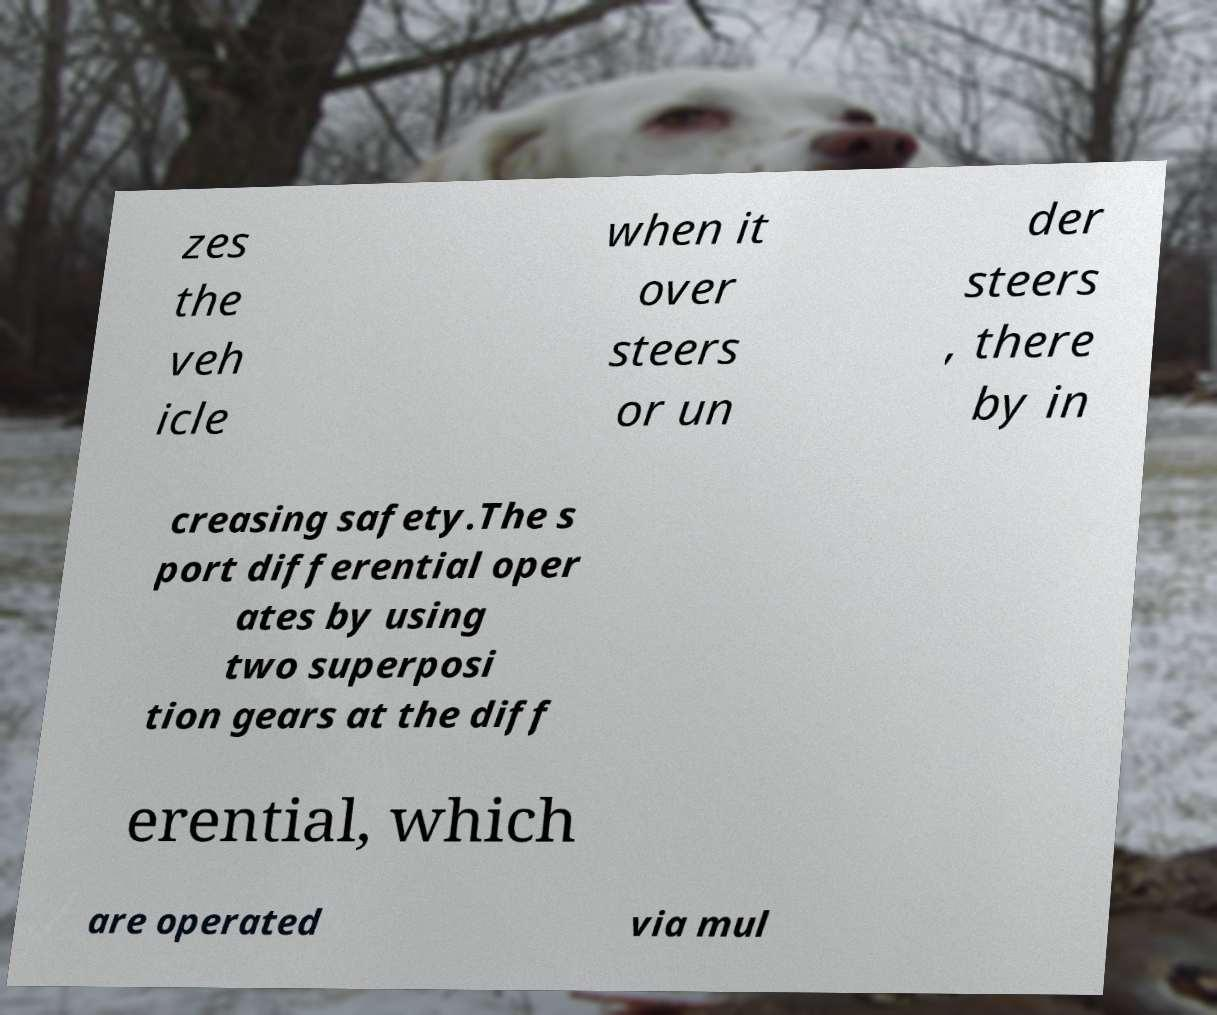Please identify and transcribe the text found in this image. zes the veh icle when it over steers or un der steers , there by in creasing safety.The s port differential oper ates by using two superposi tion gears at the diff erential, which are operated via mul 